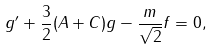Convert formula to latex. <formula><loc_0><loc_0><loc_500><loc_500>g ^ { \prime } + \frac { 3 } { 2 } ( A + C ) g - \frac { m } { \sqrt { 2 } } f = 0 ,</formula> 